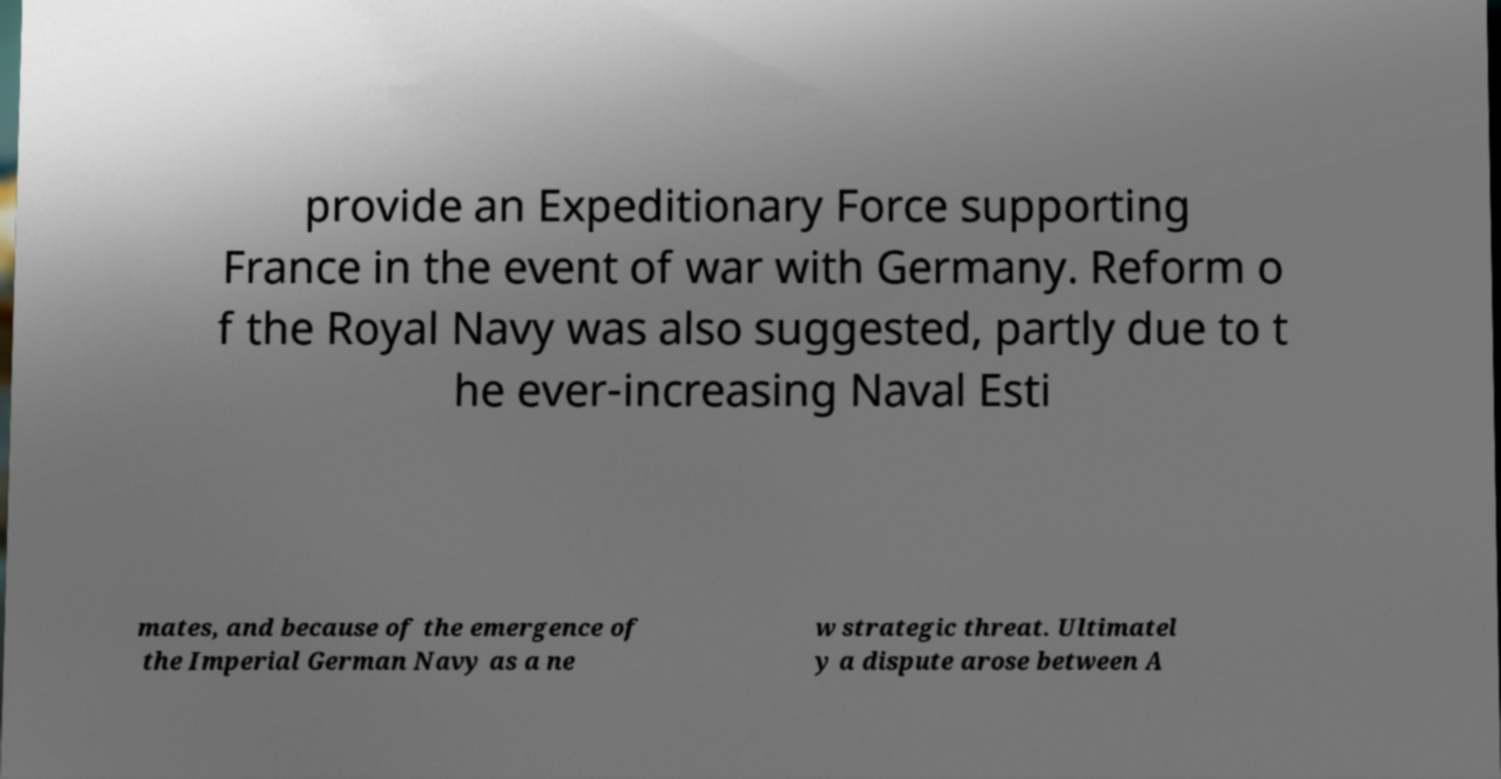For documentation purposes, I need the text within this image transcribed. Could you provide that? provide an Expeditionary Force supporting France in the event of war with Germany. Reform o f the Royal Navy was also suggested, partly due to t he ever-increasing Naval Esti mates, and because of the emergence of the Imperial German Navy as a ne w strategic threat. Ultimatel y a dispute arose between A 